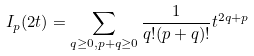Convert formula to latex. <formula><loc_0><loc_0><loc_500><loc_500>I _ { p } ( 2 t ) = \sum _ { q \geq 0 , p + q \geq 0 } \frac { 1 } { q ! ( p + q ) ! } t ^ { 2 q + p }</formula> 